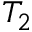<formula> <loc_0><loc_0><loc_500><loc_500>T _ { 2 }</formula> 